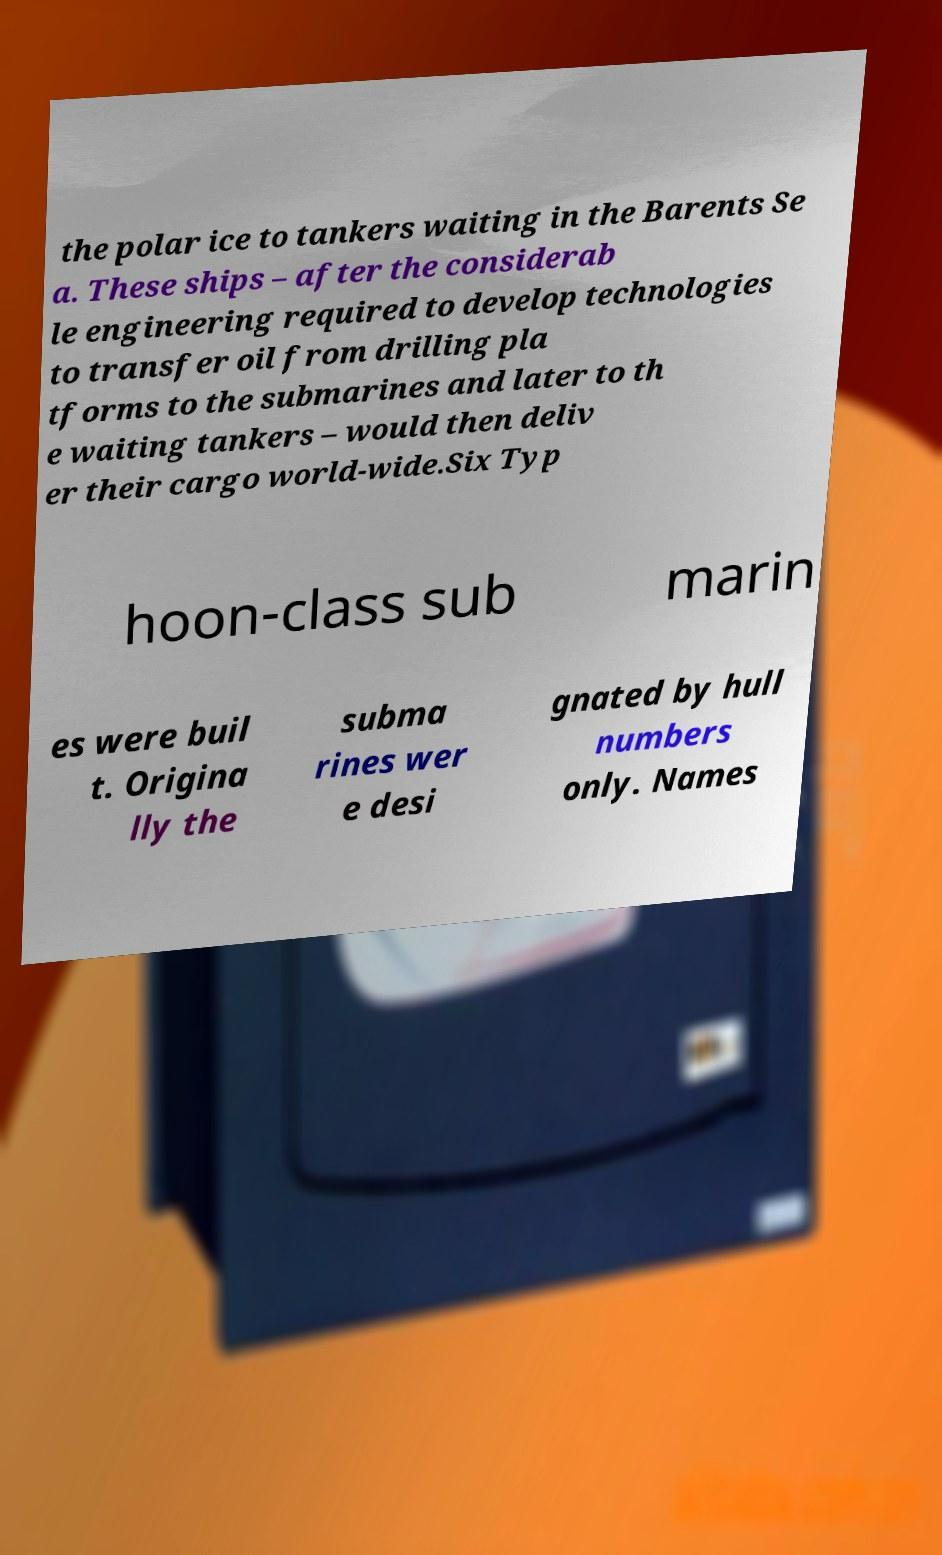I need the written content from this picture converted into text. Can you do that? the polar ice to tankers waiting in the Barents Se a. These ships – after the considerab le engineering required to develop technologies to transfer oil from drilling pla tforms to the submarines and later to th e waiting tankers – would then deliv er their cargo world-wide.Six Typ hoon-class sub marin es were buil t. Origina lly the subma rines wer e desi gnated by hull numbers only. Names 